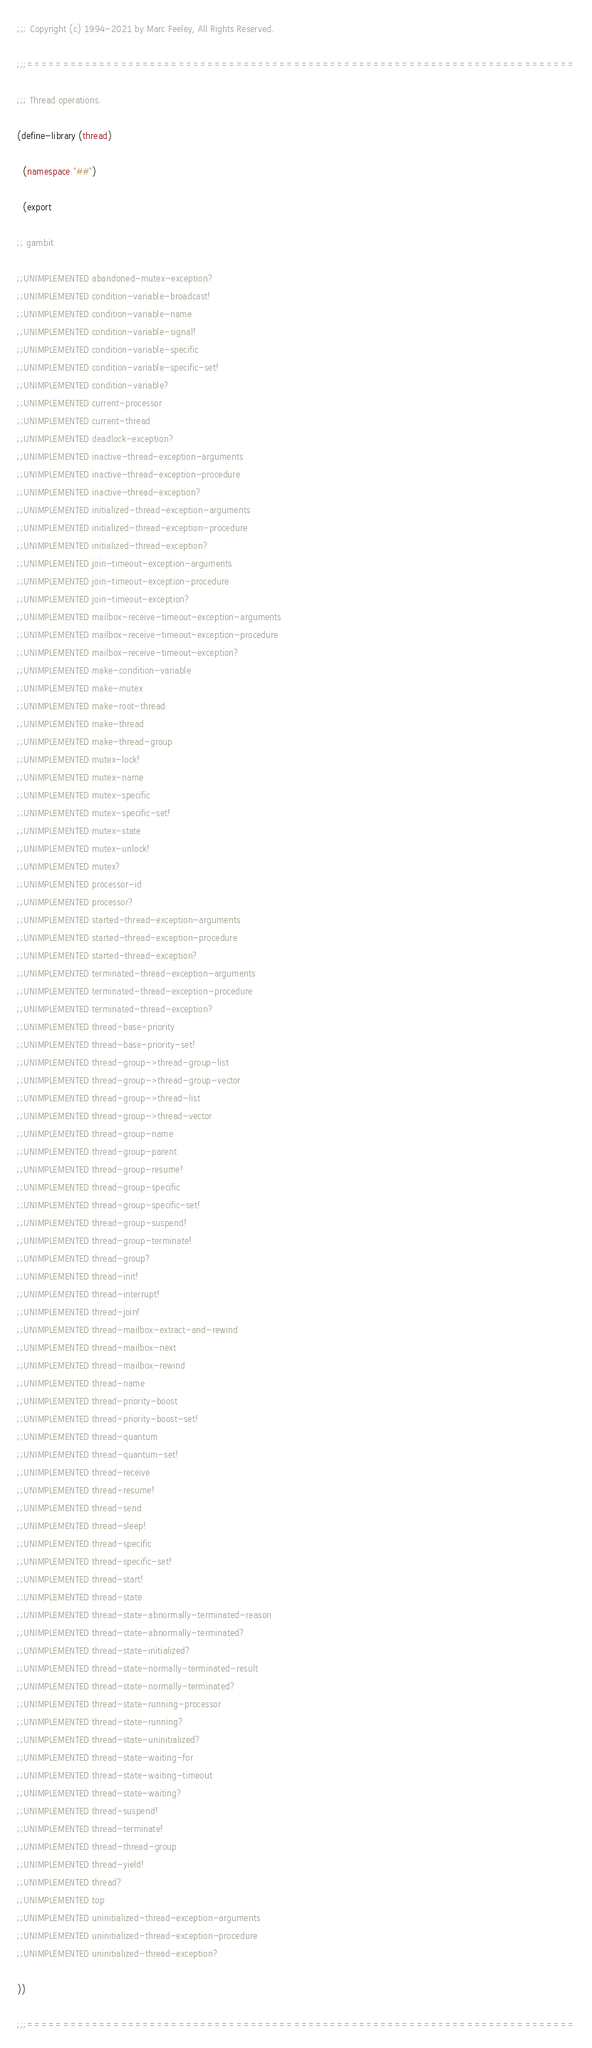<code> <loc_0><loc_0><loc_500><loc_500><_Scheme_>
;;; Copyright (c) 1994-2021 by Marc Feeley, All Rights Reserved.

;;;============================================================================

;;; Thread operations.

(define-library (thread)

  (namespace "##")

  (export

;; gambit

;;UNIMPLEMENTED abandoned-mutex-exception?
;;UNIMPLEMENTED condition-variable-broadcast!
;;UNIMPLEMENTED condition-variable-name
;;UNIMPLEMENTED condition-variable-signal!
;;UNIMPLEMENTED condition-variable-specific
;;UNIMPLEMENTED condition-variable-specific-set!
;;UNIMPLEMENTED condition-variable?
;;UNIMPLEMENTED current-processor
;;UNIMPLEMENTED current-thread
;;UNIMPLEMENTED deadlock-exception?
;;UNIMPLEMENTED inactive-thread-exception-arguments
;;UNIMPLEMENTED inactive-thread-exception-procedure
;;UNIMPLEMENTED inactive-thread-exception?
;;UNIMPLEMENTED initialized-thread-exception-arguments
;;UNIMPLEMENTED initialized-thread-exception-procedure
;;UNIMPLEMENTED initialized-thread-exception?
;;UNIMPLEMENTED join-timeout-exception-arguments
;;UNIMPLEMENTED join-timeout-exception-procedure
;;UNIMPLEMENTED join-timeout-exception?
;;UNIMPLEMENTED mailbox-receive-timeout-exception-arguments
;;UNIMPLEMENTED mailbox-receive-timeout-exception-procedure
;;UNIMPLEMENTED mailbox-receive-timeout-exception?
;;UNIMPLEMENTED make-condition-variable
;;UNIMPLEMENTED make-mutex
;;UNIMPLEMENTED make-root-thread
;;UNIMPLEMENTED make-thread
;;UNIMPLEMENTED make-thread-group
;;UNIMPLEMENTED mutex-lock!
;;UNIMPLEMENTED mutex-name
;;UNIMPLEMENTED mutex-specific
;;UNIMPLEMENTED mutex-specific-set!
;;UNIMPLEMENTED mutex-state
;;UNIMPLEMENTED mutex-unlock!
;;UNIMPLEMENTED mutex?
;;UNIMPLEMENTED processor-id
;;UNIMPLEMENTED processor?
;;UNIMPLEMENTED started-thread-exception-arguments
;;UNIMPLEMENTED started-thread-exception-procedure
;;UNIMPLEMENTED started-thread-exception?
;;UNIMPLEMENTED terminated-thread-exception-arguments
;;UNIMPLEMENTED terminated-thread-exception-procedure
;;UNIMPLEMENTED terminated-thread-exception?
;;UNIMPLEMENTED thread-base-priority
;;UNIMPLEMENTED thread-base-priority-set!
;;UNIMPLEMENTED thread-group->thread-group-list
;;UNIMPLEMENTED thread-group->thread-group-vector
;;UNIMPLEMENTED thread-group->thread-list
;;UNIMPLEMENTED thread-group->thread-vector
;;UNIMPLEMENTED thread-group-name
;;UNIMPLEMENTED thread-group-parent
;;UNIMPLEMENTED thread-group-resume!
;;UNIMPLEMENTED thread-group-specific
;;UNIMPLEMENTED thread-group-specific-set!
;;UNIMPLEMENTED thread-group-suspend!
;;UNIMPLEMENTED thread-group-terminate!
;;UNIMPLEMENTED thread-group?
;;UNIMPLEMENTED thread-init!
;;UNIMPLEMENTED thread-interrupt!
;;UNIMPLEMENTED thread-join!
;;UNIMPLEMENTED thread-mailbox-extract-and-rewind
;;UNIMPLEMENTED thread-mailbox-next
;;UNIMPLEMENTED thread-mailbox-rewind
;;UNIMPLEMENTED thread-name
;;UNIMPLEMENTED thread-priority-boost
;;UNIMPLEMENTED thread-priority-boost-set!
;;UNIMPLEMENTED thread-quantum
;;UNIMPLEMENTED thread-quantum-set!
;;UNIMPLEMENTED thread-receive
;;UNIMPLEMENTED thread-resume!
;;UNIMPLEMENTED thread-send
;;UNIMPLEMENTED thread-sleep!
;;UNIMPLEMENTED thread-specific
;;UNIMPLEMENTED thread-specific-set!
;;UNIMPLEMENTED thread-start!
;;UNIMPLEMENTED thread-state
;;UNIMPLEMENTED thread-state-abnormally-terminated-reason
;;UNIMPLEMENTED thread-state-abnormally-terminated?
;;UNIMPLEMENTED thread-state-initialized?
;;UNIMPLEMENTED thread-state-normally-terminated-result
;;UNIMPLEMENTED thread-state-normally-terminated?
;;UNIMPLEMENTED thread-state-running-processor
;;UNIMPLEMENTED thread-state-running?
;;UNIMPLEMENTED thread-state-uninitialized?
;;UNIMPLEMENTED thread-state-waiting-for
;;UNIMPLEMENTED thread-state-waiting-timeout
;;UNIMPLEMENTED thread-state-waiting?
;;UNIMPLEMENTED thread-suspend!
;;UNIMPLEMENTED thread-terminate!
;;UNIMPLEMENTED thread-thread-group
;;UNIMPLEMENTED thread-yield!
;;UNIMPLEMENTED thread?
;;UNIMPLEMENTED top
;;UNIMPLEMENTED uninitialized-thread-exception-arguments
;;UNIMPLEMENTED uninitialized-thread-exception-procedure
;;UNIMPLEMENTED uninitialized-thread-exception?

))

;;;============================================================================
</code> 